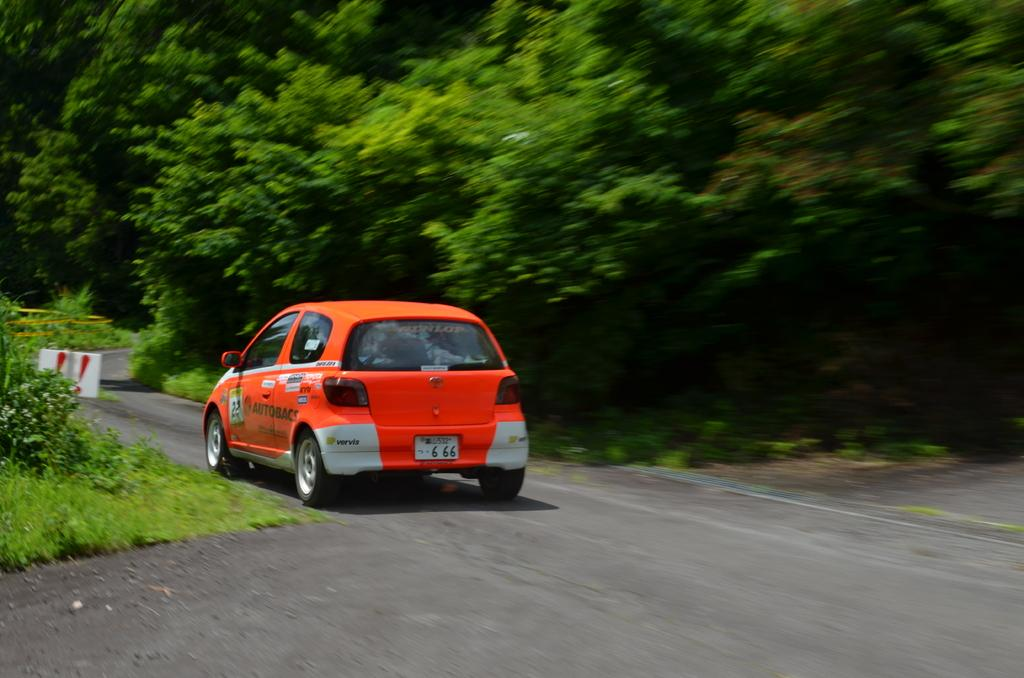What type of surface can be seen in the image? There is a grass surface in the image. What else is present in the image besides the grass surface? There is a road in the image. What can be seen on the road? There is a car on the road. What is the color of the car? The car is orange in color. What type of vegetation is visible in the image? There are trees visible in the image. How much money is being exchanged at the party in the image? There is no party or money exchange present in the image. What type of cannon is visible in the image? There is no cannon present in the image. 